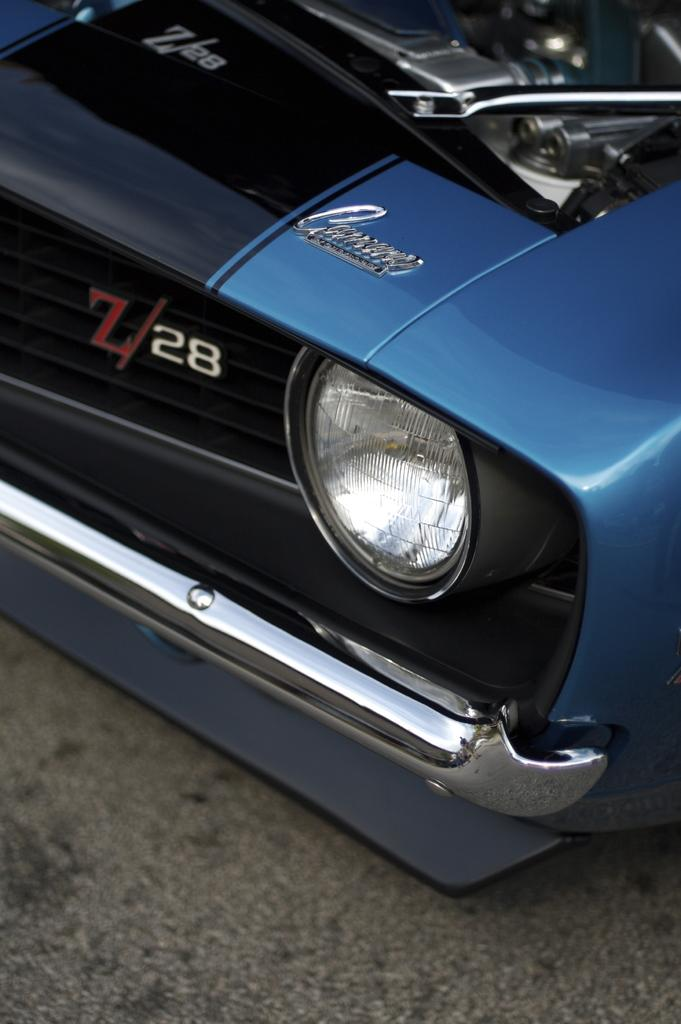What is the main subject of the image? There is a vehicle in the image. Can you describe the color of the vehicle? The vehicle is blue in color. What type of pleasure can be seen enjoying the zoo in the image? There is no reference to pleasure or a zoo in the image, so it's not possible to determine what, if any, pleasure might be enjoying a zoo. 